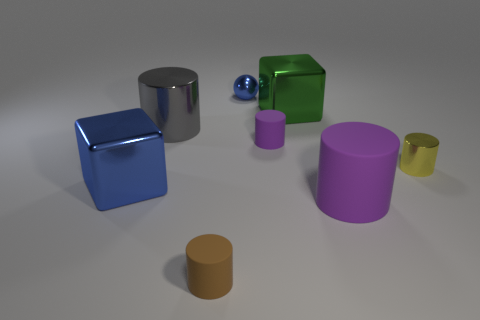Add 1 large green blocks. How many objects exist? 9 Subtract all gray shiny cylinders. How many cylinders are left? 4 Subtract all purple cylinders. How many cylinders are left? 3 Subtract all cyan blocks. How many purple cylinders are left? 2 Subtract 1 blue spheres. How many objects are left? 7 Subtract all blocks. How many objects are left? 6 Subtract 1 cylinders. How many cylinders are left? 4 Subtract all yellow cylinders. Subtract all gray balls. How many cylinders are left? 4 Subtract all large red balls. Subtract all big purple rubber cylinders. How many objects are left? 7 Add 5 big purple things. How many big purple things are left? 6 